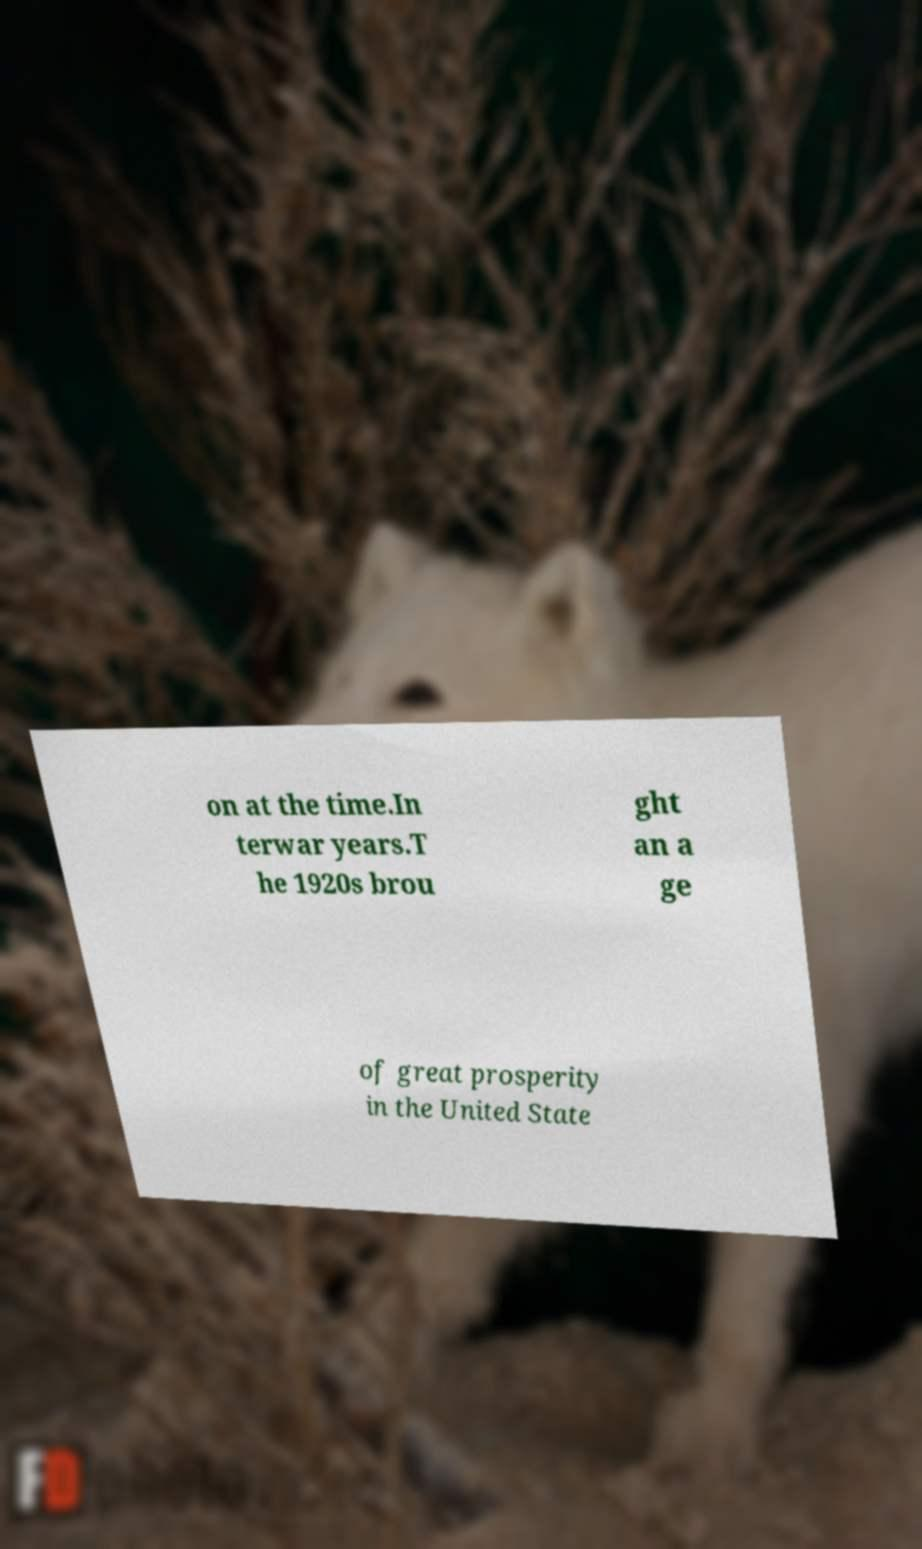Can you accurately transcribe the text from the provided image for me? on at the time.In terwar years.T he 1920s brou ght an a ge of great prosperity in the United State 